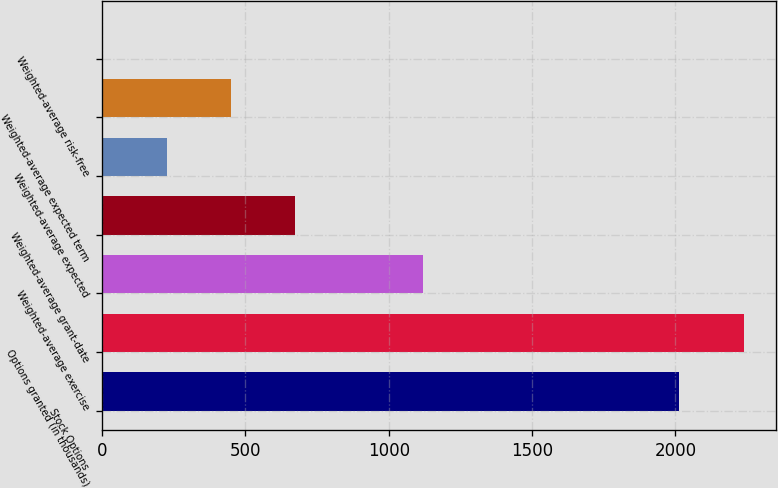<chart> <loc_0><loc_0><loc_500><loc_500><bar_chart><fcel>Stock Options<fcel>Options granted (in thousands)<fcel>Weighted-average exercise<fcel>Weighted-average grant-date<fcel>Weighted-average expected<fcel>Weighted-average expected term<fcel>Weighted-average risk-free<nl><fcel>2014<fcel>2240<fcel>1120.85<fcel>673.19<fcel>225.53<fcel>449.36<fcel>1.7<nl></chart> 